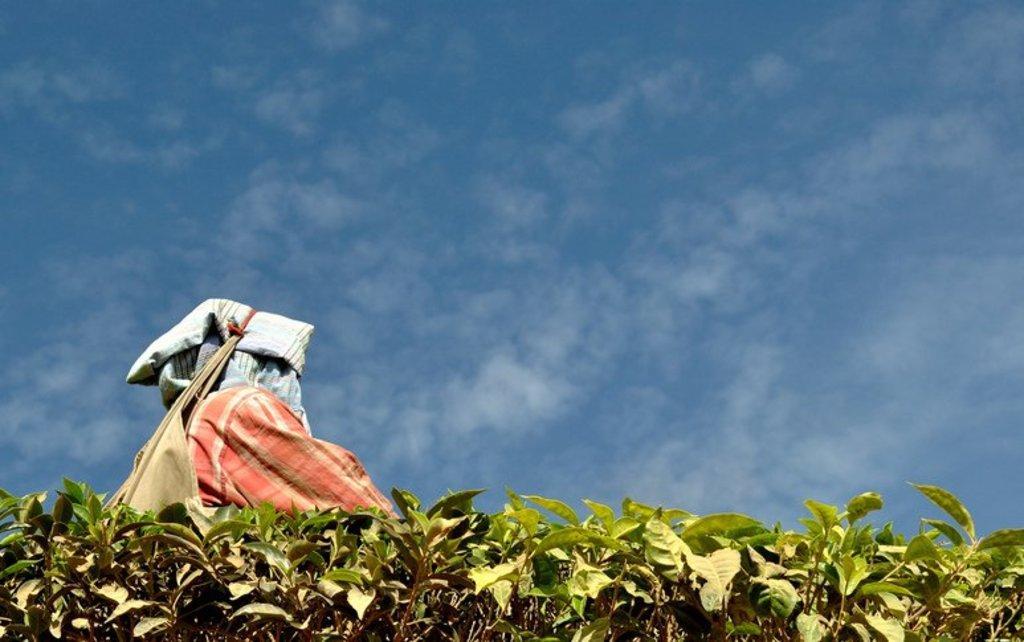Can you describe this image briefly? In the picture I can see planets, clothes and some other objects. In the background I can see the sky. 